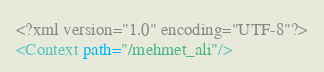<code> <loc_0><loc_0><loc_500><loc_500><_XML_><?xml version="1.0" encoding="UTF-8"?>
<Context path="/mehmet_ali"/>
</code> 